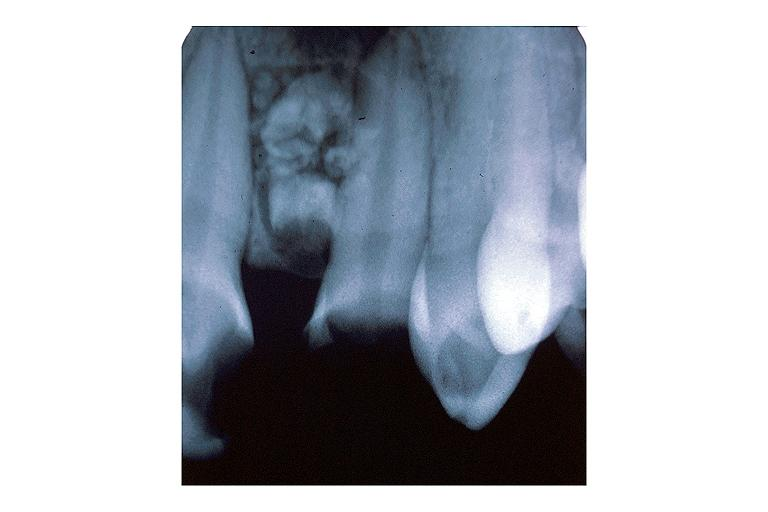what does this image show?
Answer the question using a single word or phrase. Compound odontoma 